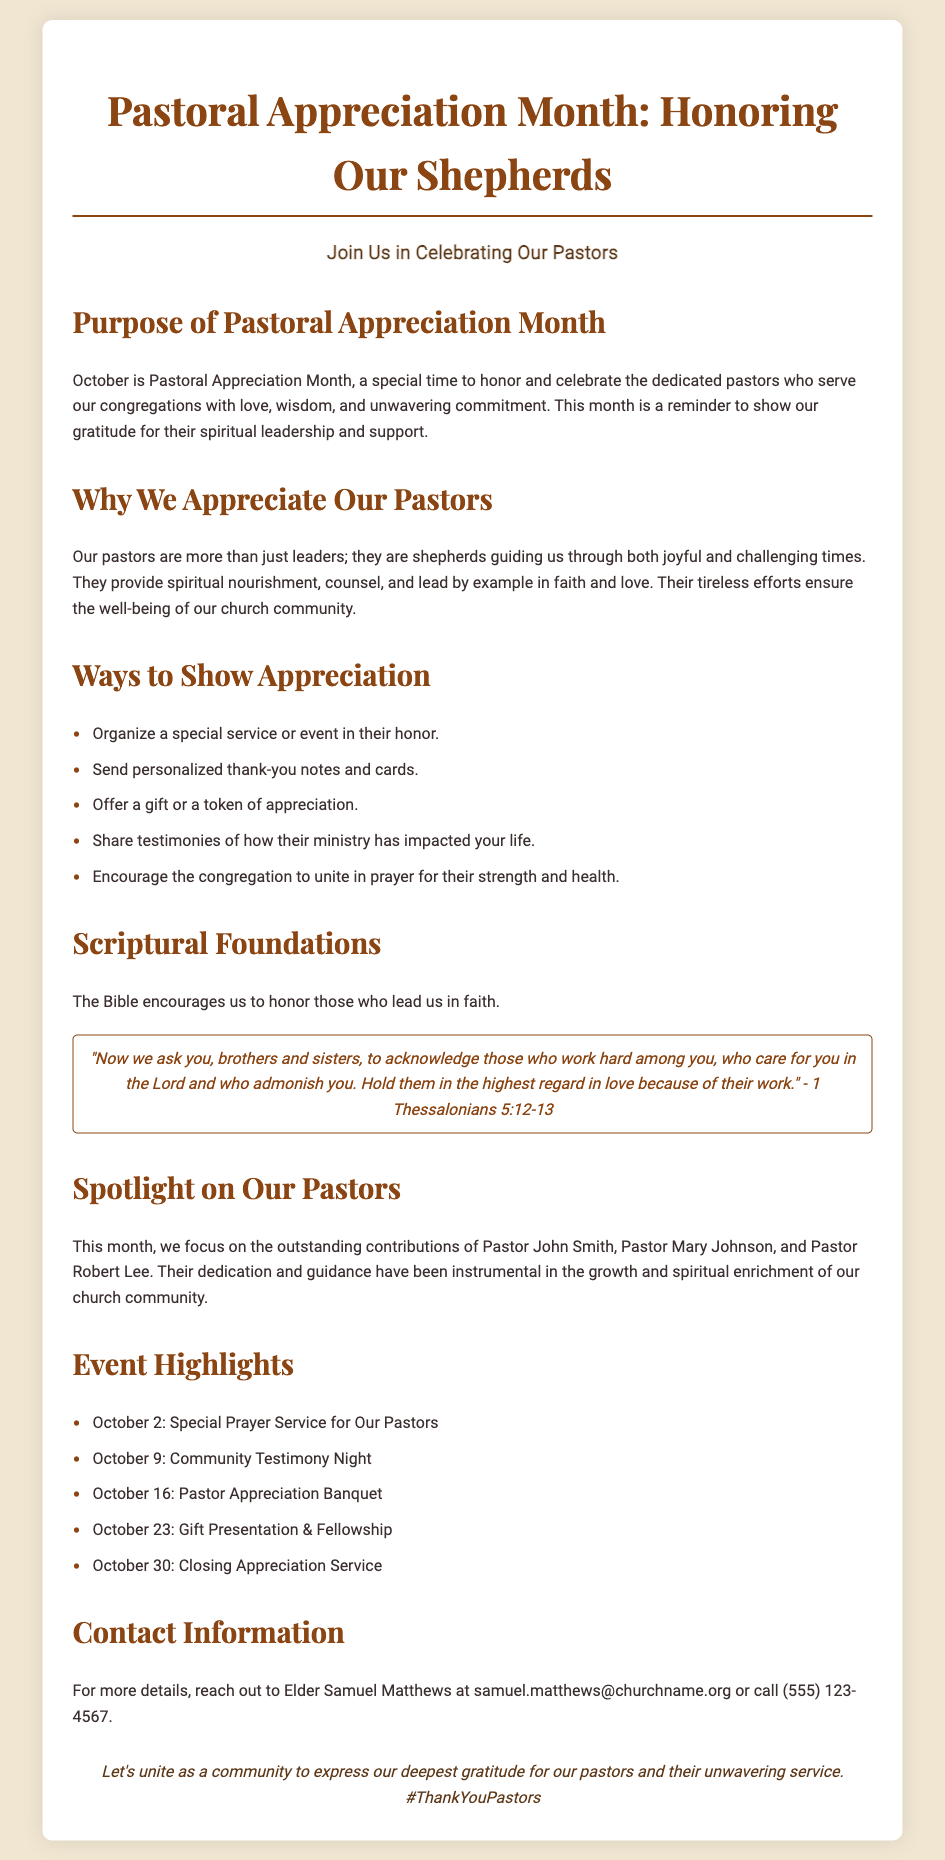What is the title of the flyer? The title of the flyer is prominently displayed at the top of the document.
Answer: Pastoral Appreciation Month: Honoring Our Shepherds What is the purpose of Pastoral Appreciation Month? The document states that the purpose is to honor and celebrate dedicated pastors.
Answer: To honor and celebrate the dedicated pastors Who is organizing the special service on October 2? The special prayer service is part of the events listed in the document.
Answer: Community What scripture is referenced regarding honoring pastors? The document includes a quoted scripture about acknowledging those who lead in faith.
Answer: 1 Thessalonians 5:12-13 How many pastors are specifically mentioned in the spotlight section? The document lists the names of the pastors who are highlighted during the month.
Answer: Three What is one way the community can show appreciation? The document provides a few ways to show appreciation to pastors.
Answer: Organize a special service or event in their honor When is the Pastor Appreciation Banquet scheduled? The date of the Pastor Appreciation Banquet is mentioned in the event highlights section.
Answer: October 16 Who should be contacted for more information? The document lists a specific elder's name and contact details for inquiries.
Answer: Elder Samuel Matthews 